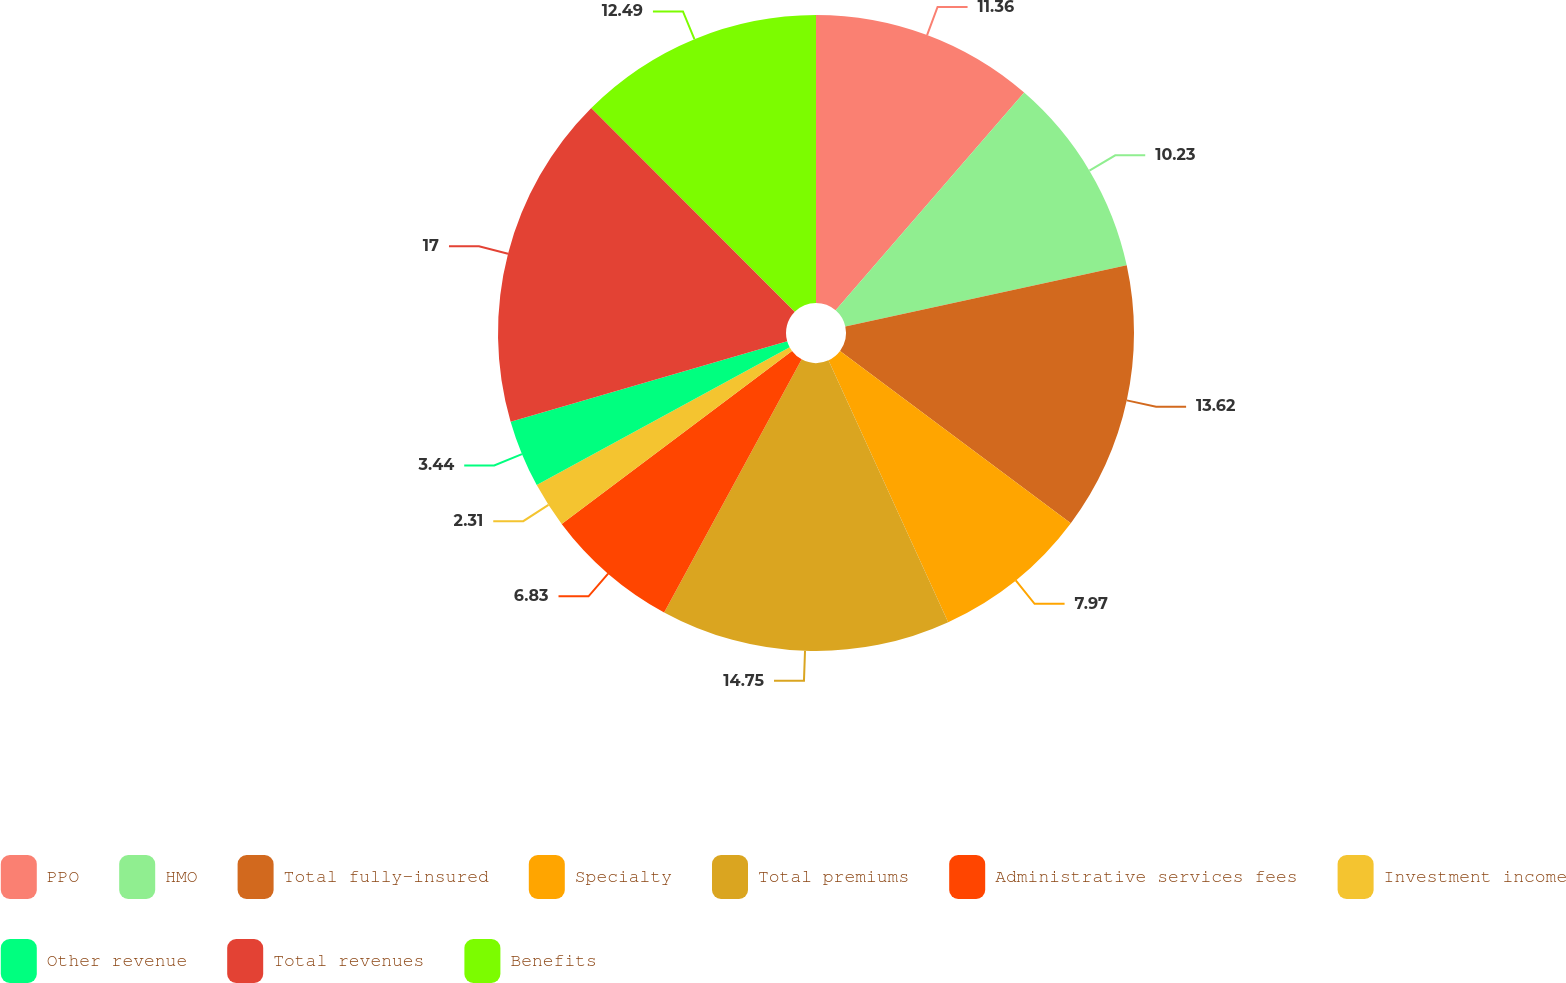Convert chart. <chart><loc_0><loc_0><loc_500><loc_500><pie_chart><fcel>PPO<fcel>HMO<fcel>Total fully-insured<fcel>Specialty<fcel>Total premiums<fcel>Administrative services fees<fcel>Investment income<fcel>Other revenue<fcel>Total revenues<fcel>Benefits<nl><fcel>11.36%<fcel>10.23%<fcel>13.62%<fcel>7.97%<fcel>14.75%<fcel>6.83%<fcel>2.31%<fcel>3.44%<fcel>17.01%<fcel>12.49%<nl></chart> 